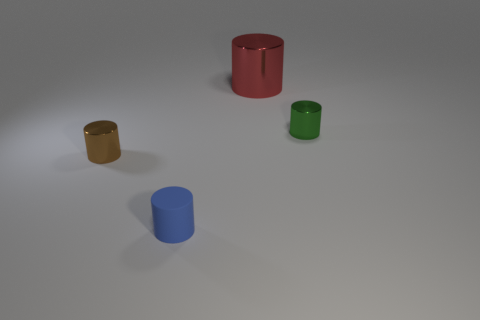Does the brown shiny thing have the same size as the cylinder behind the green cylinder?
Ensure brevity in your answer.  No. There is a thing that is left of the small cylinder in front of the brown metal cylinder; what size is it?
Provide a succinct answer. Small. What number of tiny green cylinders have the same material as the red cylinder?
Your response must be concise. 1. Are any large blue shiny things visible?
Your response must be concise. No. What size is the thing that is right of the big object?
Your answer should be compact. Small. How many small cylinders are the same color as the matte thing?
Ensure brevity in your answer.  0. How many spheres are either tiny brown matte things or brown objects?
Your answer should be very brief. 0. Is there a red rubber ball of the same size as the brown shiny cylinder?
Make the answer very short. No. How many things are tiny shiny objects that are on the right side of the small matte object or small green things?
Provide a short and direct response. 1. Are the big thing and the brown cylinder that is in front of the tiny green metallic thing made of the same material?
Give a very brief answer. Yes. 